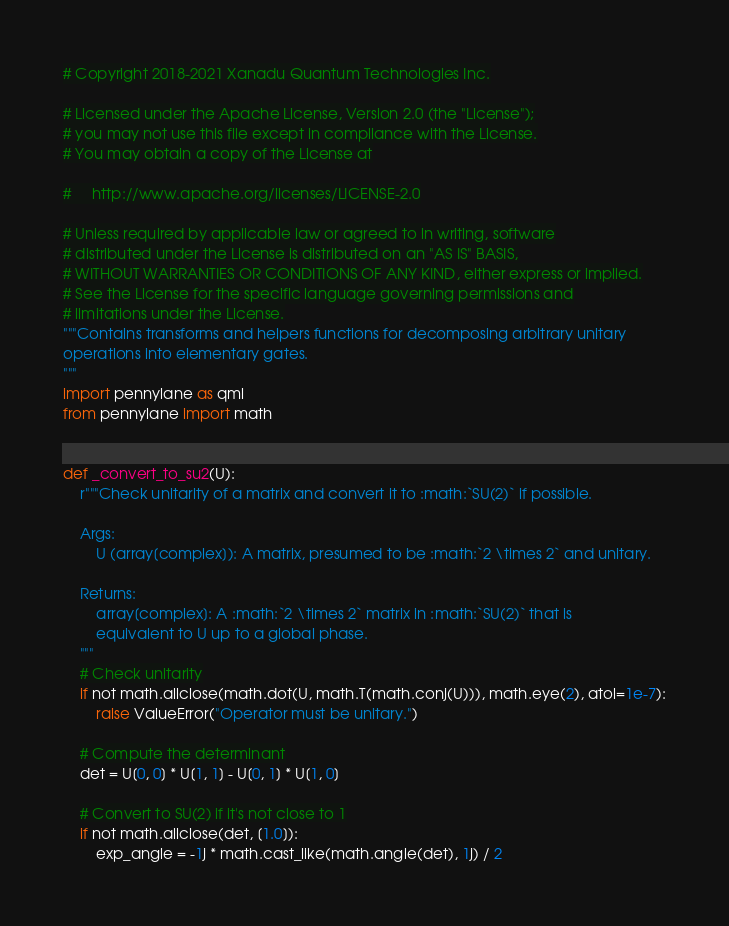Convert code to text. <code><loc_0><loc_0><loc_500><loc_500><_Python_># Copyright 2018-2021 Xanadu Quantum Technologies Inc.

# Licensed under the Apache License, Version 2.0 (the "License");
# you may not use this file except in compliance with the License.
# You may obtain a copy of the License at

#     http://www.apache.org/licenses/LICENSE-2.0

# Unless required by applicable law or agreed to in writing, software
# distributed under the License is distributed on an "AS IS" BASIS,
# WITHOUT WARRANTIES OR CONDITIONS OF ANY KIND, either express or implied.
# See the License for the specific language governing permissions and
# limitations under the License.
"""Contains transforms and helpers functions for decomposing arbitrary unitary
operations into elementary gates.
"""
import pennylane as qml
from pennylane import math


def _convert_to_su2(U):
    r"""Check unitarity of a matrix and convert it to :math:`SU(2)` if possible.

    Args:
        U (array[complex]): A matrix, presumed to be :math:`2 \times 2` and unitary.

    Returns:
        array[complex]: A :math:`2 \times 2` matrix in :math:`SU(2)` that is
        equivalent to U up to a global phase.
    """
    # Check unitarity
    if not math.allclose(math.dot(U, math.T(math.conj(U))), math.eye(2), atol=1e-7):
        raise ValueError("Operator must be unitary.")

    # Compute the determinant
    det = U[0, 0] * U[1, 1] - U[0, 1] * U[1, 0]

    # Convert to SU(2) if it's not close to 1
    if not math.allclose(det, [1.0]):
        exp_angle = -1j * math.cast_like(math.angle(det), 1j) / 2</code> 